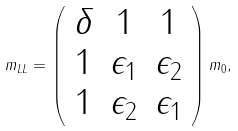<formula> <loc_0><loc_0><loc_500><loc_500>m _ { L L } = \left ( \begin{array} { c c c } \delta & 1 & 1 \\ 1 & \epsilon _ { 1 } & \epsilon _ { 2 } \\ 1 & \epsilon _ { 2 } & \epsilon _ { 1 } \end{array} \right ) m _ { 0 } ,</formula> 